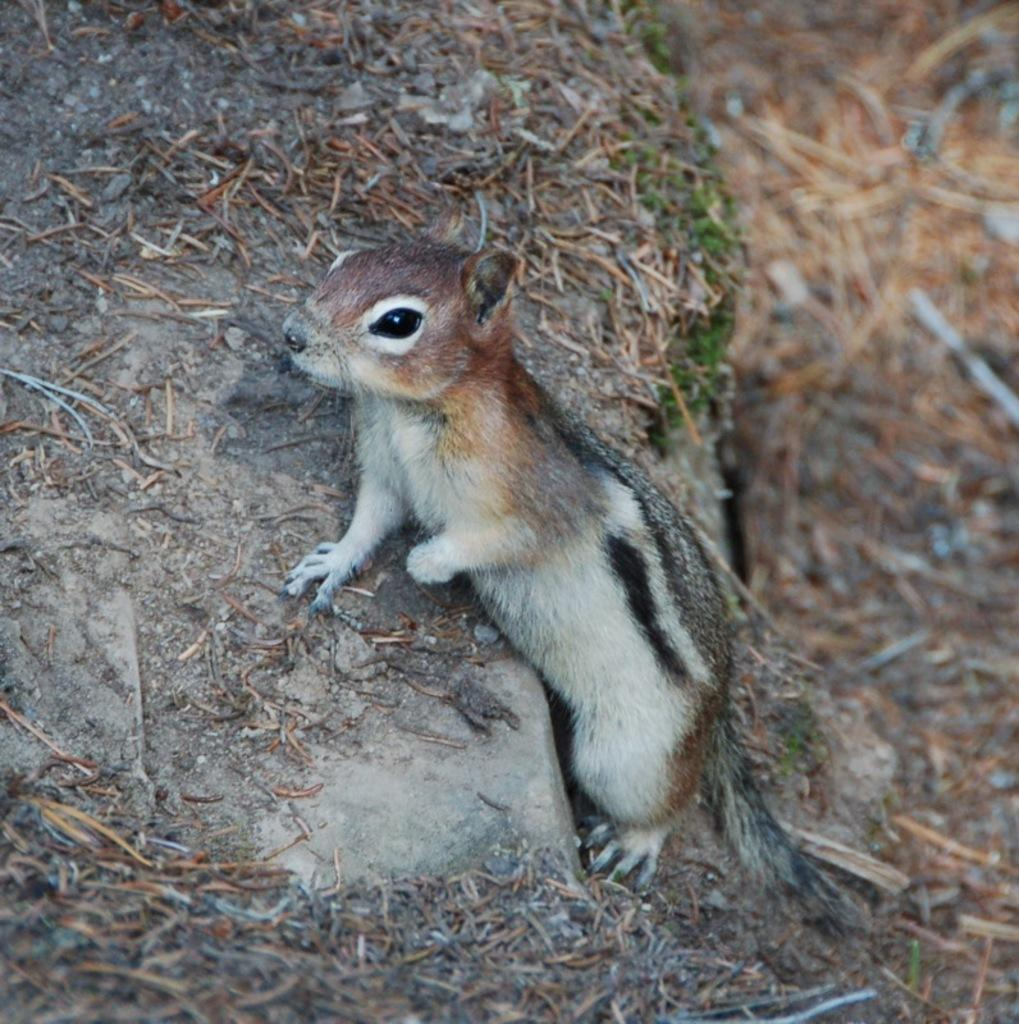What type of animal can be seen in the image? There is a squirrel in the image. What architectural feature is present in the image? There appears to be stairs in the image. What can be seen on the right side of the image? There is a blurry view on the right side of the image. What type of dirt can be seen on the squirrel's fur in the image? There is no dirt visible on the squirrel's fur in the image. What drug is the squirrel taking in the image? There is no drug present in the image, and the squirrel is not taking any drugs. 